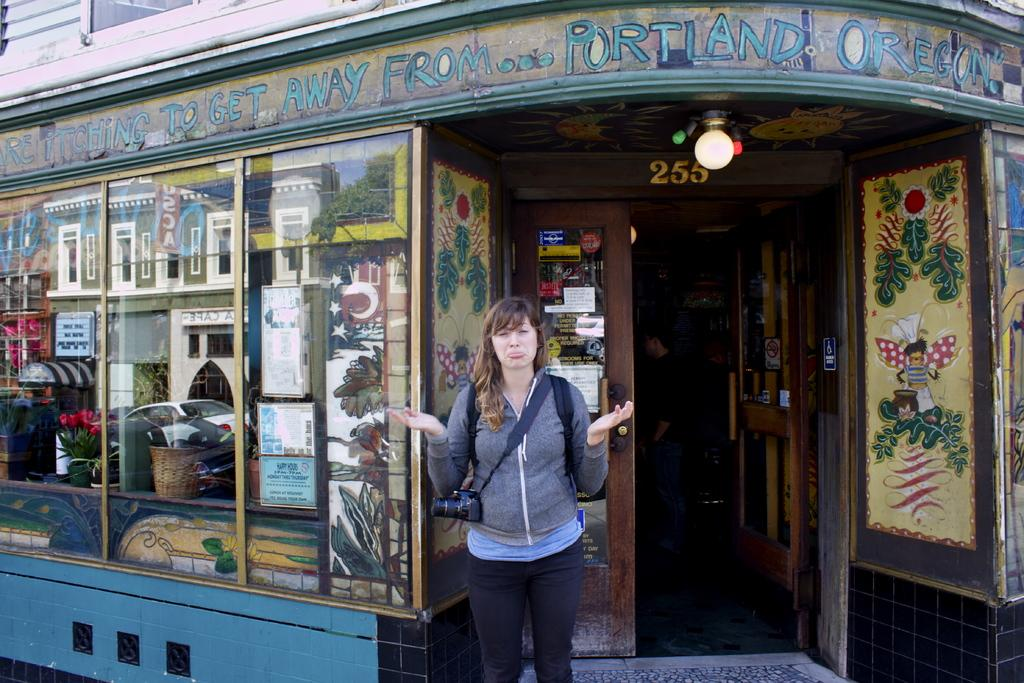What is the setting of the image? The image is an outside view. Can you describe the person in the image? The person is standing at the bottom of the image and is wearing clothes. What is the person holding in the image? The person is holding a camera. What is located behind the person in the image? The person is standing in front of a building. How many oranges are on the person's badge in the image? There is no badge or oranges present in the image. 